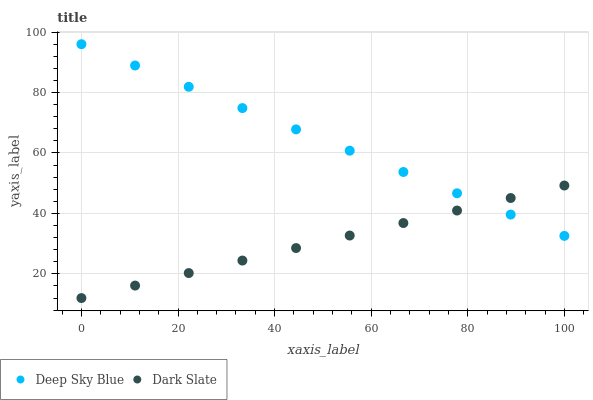Does Dark Slate have the minimum area under the curve?
Answer yes or no. Yes. Does Deep Sky Blue have the maximum area under the curve?
Answer yes or no. Yes. Does Deep Sky Blue have the minimum area under the curve?
Answer yes or no. No. Is Dark Slate the smoothest?
Answer yes or no. Yes. Is Deep Sky Blue the roughest?
Answer yes or no. Yes. Is Deep Sky Blue the smoothest?
Answer yes or no. No. Does Dark Slate have the lowest value?
Answer yes or no. Yes. Does Deep Sky Blue have the lowest value?
Answer yes or no. No. Does Deep Sky Blue have the highest value?
Answer yes or no. Yes. Does Dark Slate intersect Deep Sky Blue?
Answer yes or no. Yes. Is Dark Slate less than Deep Sky Blue?
Answer yes or no. No. Is Dark Slate greater than Deep Sky Blue?
Answer yes or no. No. 